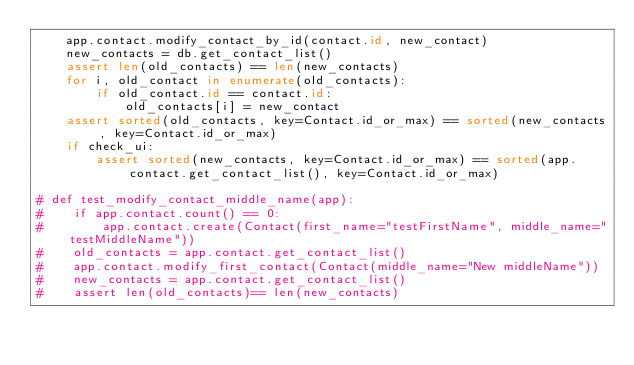Convert code to text. <code><loc_0><loc_0><loc_500><loc_500><_Python_>    app.contact.modify_contact_by_id(contact.id, new_contact)
    new_contacts = db.get_contact_list()
    assert len(old_contacts) == len(new_contacts)
    for i, old_contact in enumerate(old_contacts):
        if old_contact.id == contact.id:
            old_contacts[i] = new_contact
    assert sorted(old_contacts, key=Contact.id_or_max) == sorted(new_contacts, key=Contact.id_or_max)
    if check_ui:
        assert sorted(new_contacts, key=Contact.id_or_max) == sorted(app.contact.get_contact_list(), key=Contact.id_or_max)

# def test_modify_contact_middle_name(app):
#    if app.contact.count() == 0:
#        app.contact.create(Contact(first_name="testFirstName", middle_name="testMiddleName"))
#    old_contacts = app.contact.get_contact_list()
#    app.contact.modify_first_contact(Contact(middle_name="New middleName"))
#    new_contacts = app.contact.get_contact_list()
#    assert len(old_contacts)== len(new_contacts)
</code> 